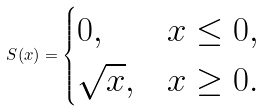Convert formula to latex. <formula><loc_0><loc_0><loc_500><loc_500>S ( x ) = \begin{cases} 0 , & x \leq 0 , \\ \sqrt { x } , & x \geq 0 . \end{cases}</formula> 